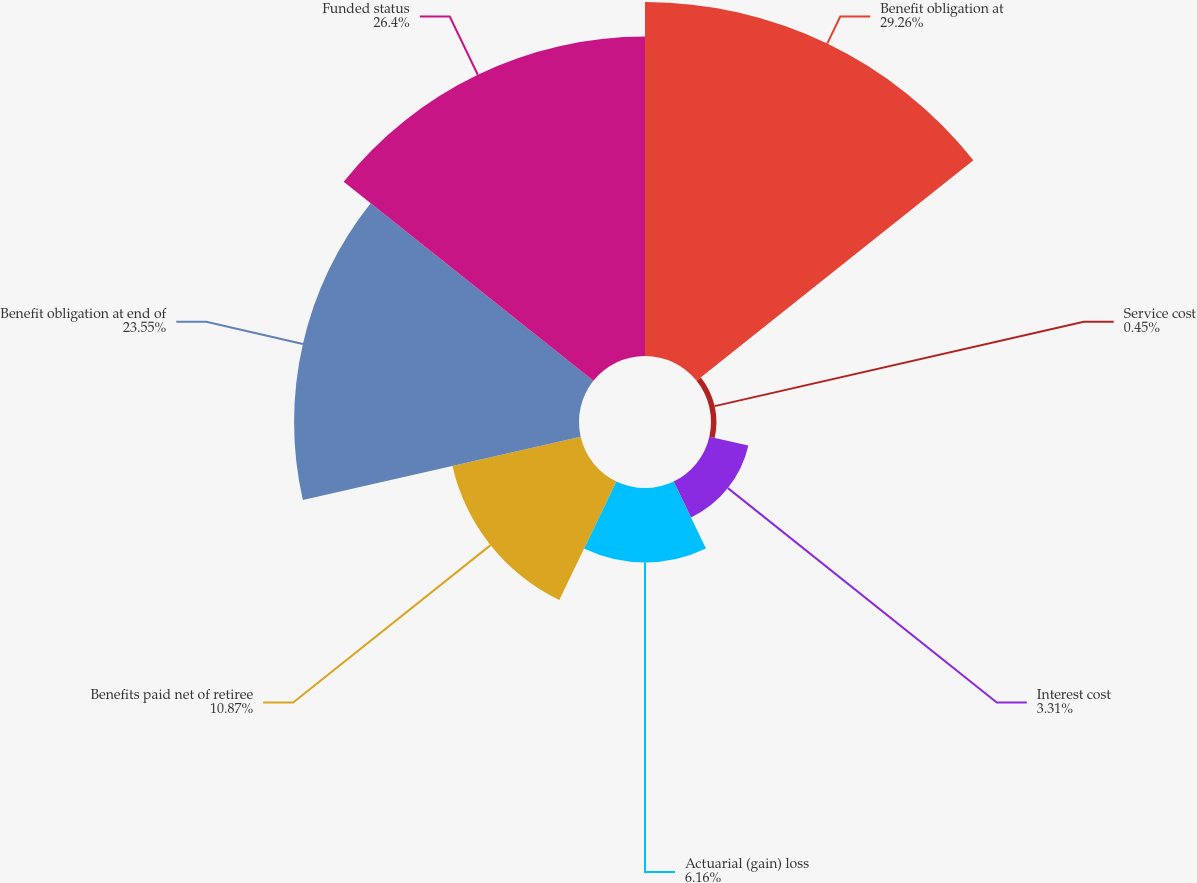Convert chart. <chart><loc_0><loc_0><loc_500><loc_500><pie_chart><fcel>Benefit obligation at<fcel>Service cost<fcel>Interest cost<fcel>Actuarial (gain) loss<fcel>Benefits paid net of retiree<fcel>Benefit obligation at end of<fcel>Funded status<nl><fcel>29.26%<fcel>0.45%<fcel>3.31%<fcel>6.16%<fcel>10.87%<fcel>23.55%<fcel>26.4%<nl></chart> 